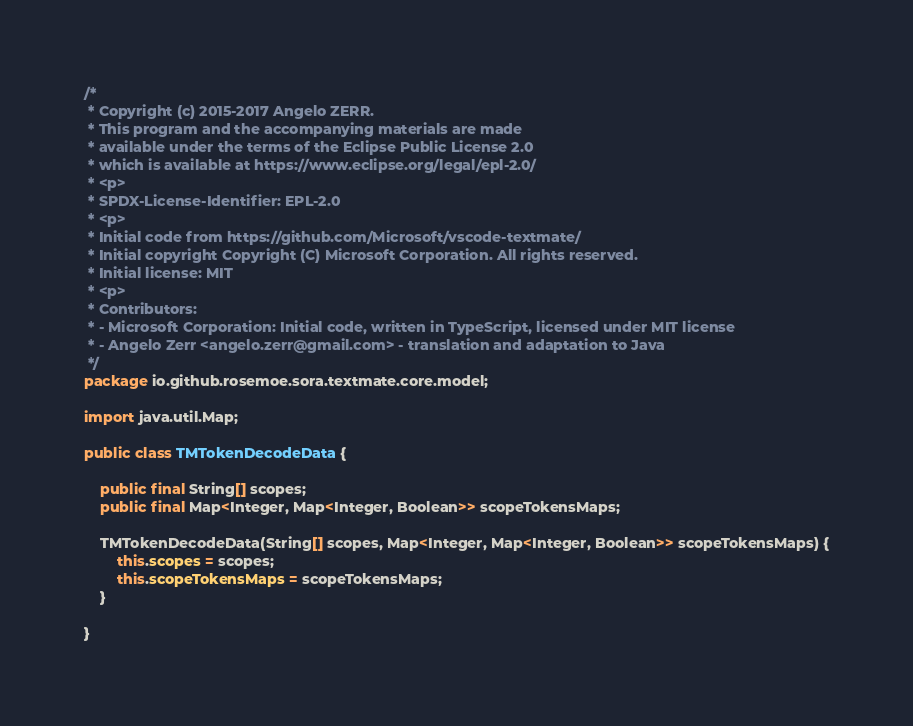<code> <loc_0><loc_0><loc_500><loc_500><_Java_>/*
 * Copyright (c) 2015-2017 Angelo ZERR.
 * This program and the accompanying materials are made
 * available under the terms of the Eclipse Public License 2.0
 * which is available at https://www.eclipse.org/legal/epl-2.0/
 * <p>
 * SPDX-License-Identifier: EPL-2.0
 * <p>
 * Initial code from https://github.com/Microsoft/vscode-textmate/
 * Initial copyright Copyright (C) Microsoft Corporation. All rights reserved.
 * Initial license: MIT
 * <p>
 * Contributors:
 * - Microsoft Corporation: Initial code, written in TypeScript, licensed under MIT license
 * - Angelo Zerr <angelo.zerr@gmail.com> - translation and adaptation to Java
 */
package io.github.rosemoe.sora.textmate.core.model;

import java.util.Map;

public class TMTokenDecodeData {

    public final String[] scopes;
    public final Map<Integer, Map<Integer, Boolean>> scopeTokensMaps;

    TMTokenDecodeData(String[] scopes, Map<Integer, Map<Integer, Boolean>> scopeTokensMaps) {
        this.scopes = scopes;
        this.scopeTokensMaps = scopeTokensMaps;
    }

}
</code> 